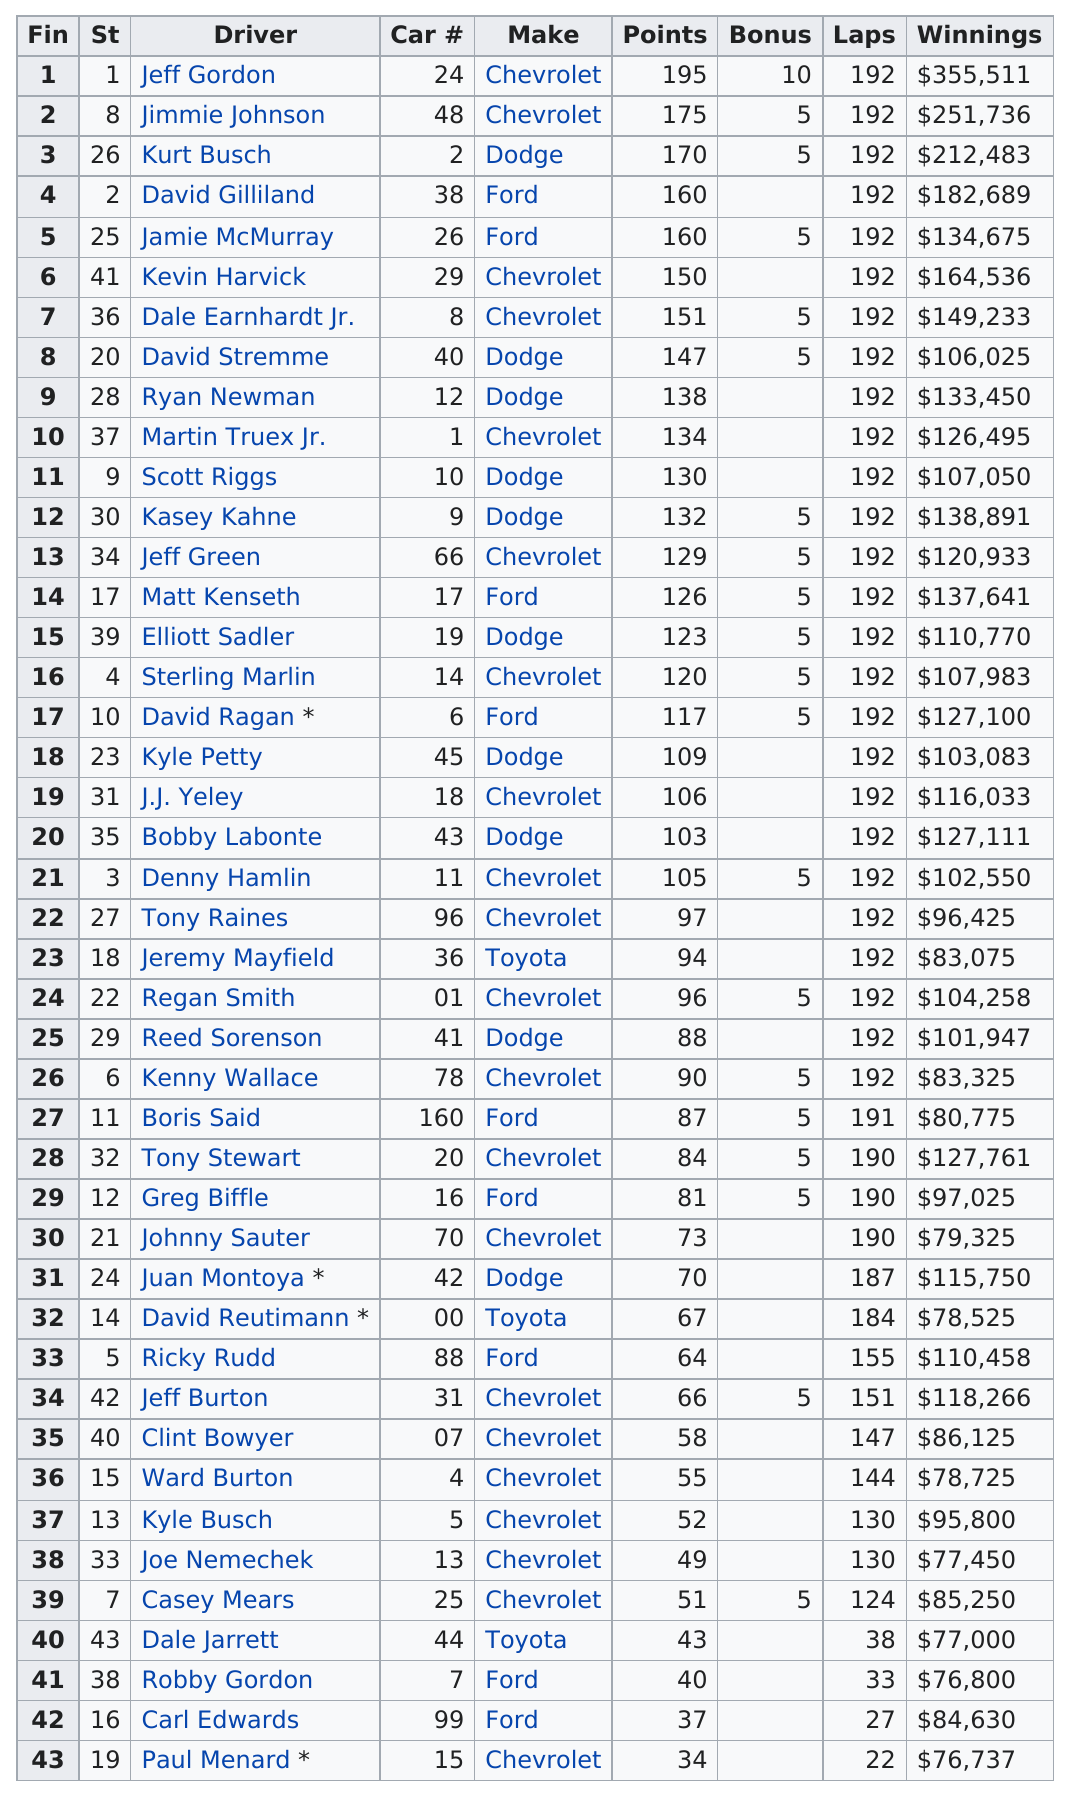Outline some significant characteristics in this image. David Gilliland and Jamie McMurray have the same number of points. Jeff Gordon holds the top position in the number of winnings on this list. Chevrolet had the most consecutive finishes at the Aarons 499 with its make. Out of the 43 listed race car drivers, 3 drove Toyotas. Jeff Gordon received the most bonus points out of all the participants. 